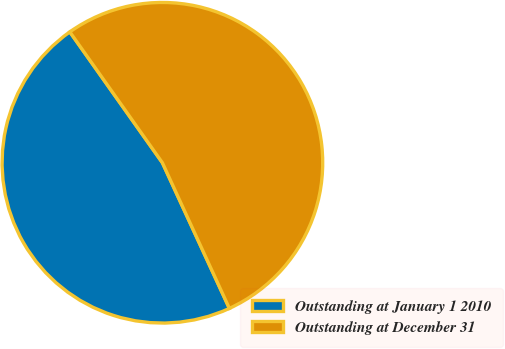<chart> <loc_0><loc_0><loc_500><loc_500><pie_chart><fcel>Outstanding at January 1 2010<fcel>Outstanding at December 31<nl><fcel>47.06%<fcel>52.94%<nl></chart> 